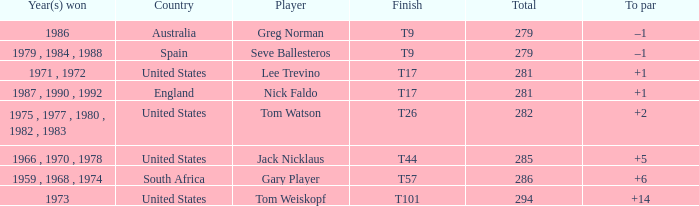Would you mind parsing the complete table? {'header': ['Year(s) won', 'Country', 'Player', 'Finish', 'Total', 'To par'], 'rows': [['1986', 'Australia', 'Greg Norman', 'T9', '279', '–1'], ['1979 , 1984 , 1988', 'Spain', 'Seve Ballesteros', 'T9', '279', '–1'], ['1971 , 1972', 'United States', 'Lee Trevino', 'T17', '281', '+1'], ['1987 , 1990 , 1992', 'England', 'Nick Faldo', 'T17', '281', '+1'], ['1975 , 1977 , 1980 , 1982 , 1983', 'United States', 'Tom Watson', 'T26', '282', '+2'], ['1966 , 1970 , 1978', 'United States', 'Jack Nicklaus', 'T44', '285', '+5'], ['1959 , 1968 , 1974', 'South Africa', 'Gary Player', 'T57', '286', '+6'], ['1973', 'United States', 'Tom Weiskopf', 'T101', '294', '+14']]} What country is Greg Norman from? Australia. 